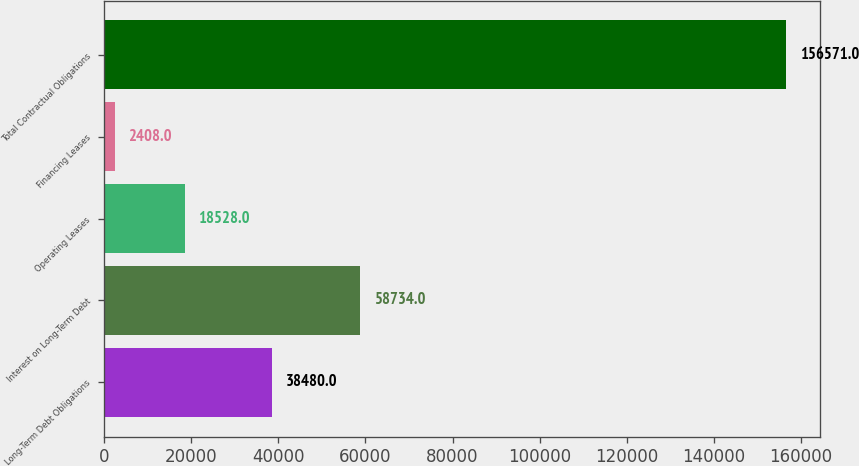Convert chart. <chart><loc_0><loc_0><loc_500><loc_500><bar_chart><fcel>Long-Term Debt Obligations<fcel>Interest on Long-Term Debt<fcel>Operating Leases<fcel>Financing Leases<fcel>Total Contractual Obligations<nl><fcel>38480<fcel>58734<fcel>18528<fcel>2408<fcel>156571<nl></chart> 